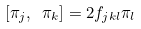Convert formula to latex. <formula><loc_0><loc_0><loc_500><loc_500>[ \pi _ { j } , \ \pi _ { k } ] = 2 f _ { j k l } \pi _ { l }</formula> 